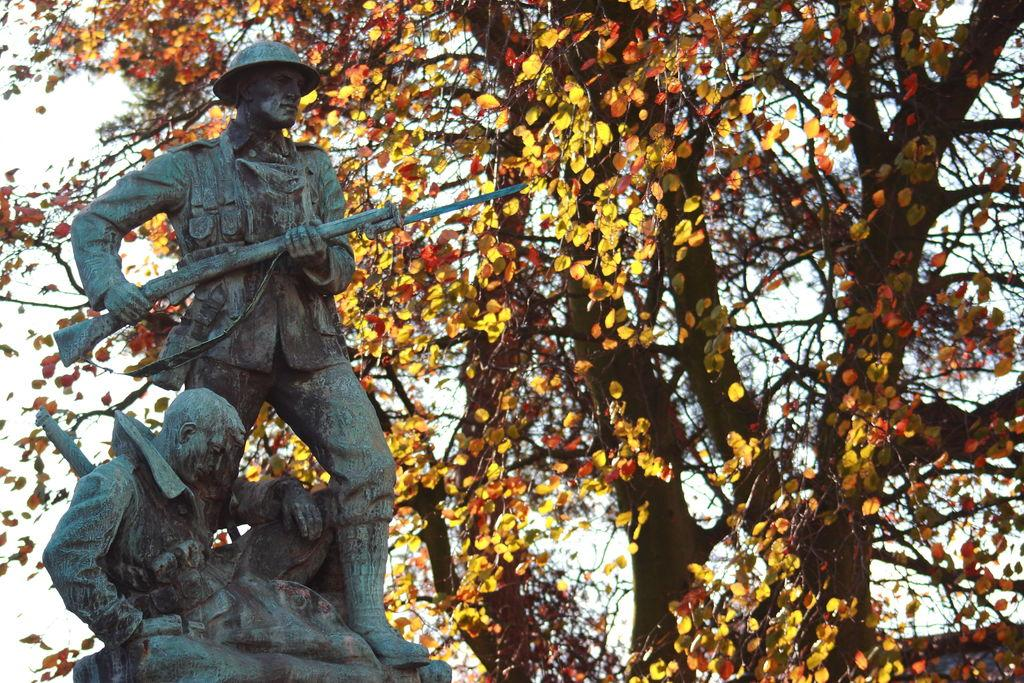What is the main subject of the sculptures in the image? There is a sculpture of a man standing and holding a weapon, and another sculpture of a man sitting. What is the man in the standing sculpture holding? The man in the standing sculpture is holding a weapon. What type of vegetation is present in the image? There are trees with branches and leaves in the image. What is the color of the leaves on the trees? The leaves have a yellow and reddish color. How many friends are sitting on the railway in the image? There is no railway or friends present in the image; it features sculptures of men and trees with leaves. 